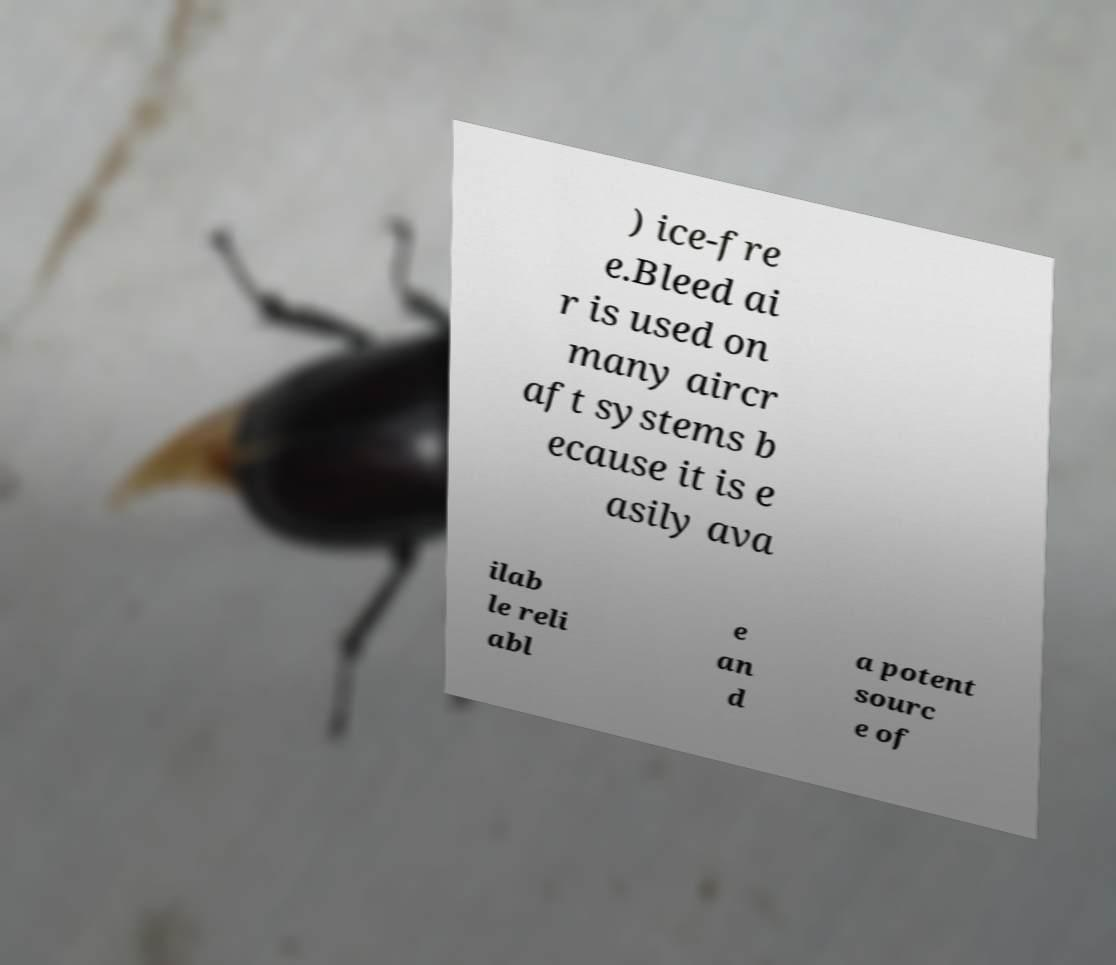I need the written content from this picture converted into text. Can you do that? ) ice-fre e.Bleed ai r is used on many aircr aft systems b ecause it is e asily ava ilab le reli abl e an d a potent sourc e of 